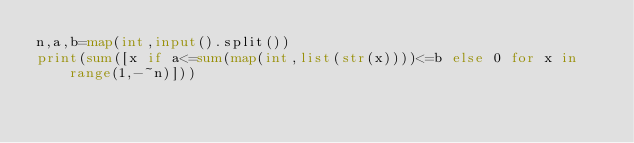<code> <loc_0><loc_0><loc_500><loc_500><_Python_>n,a,b=map(int,input().split())
print(sum([x if a<=sum(map(int,list(str(x))))<=b else 0 for x in range(1,-~n)]))</code> 